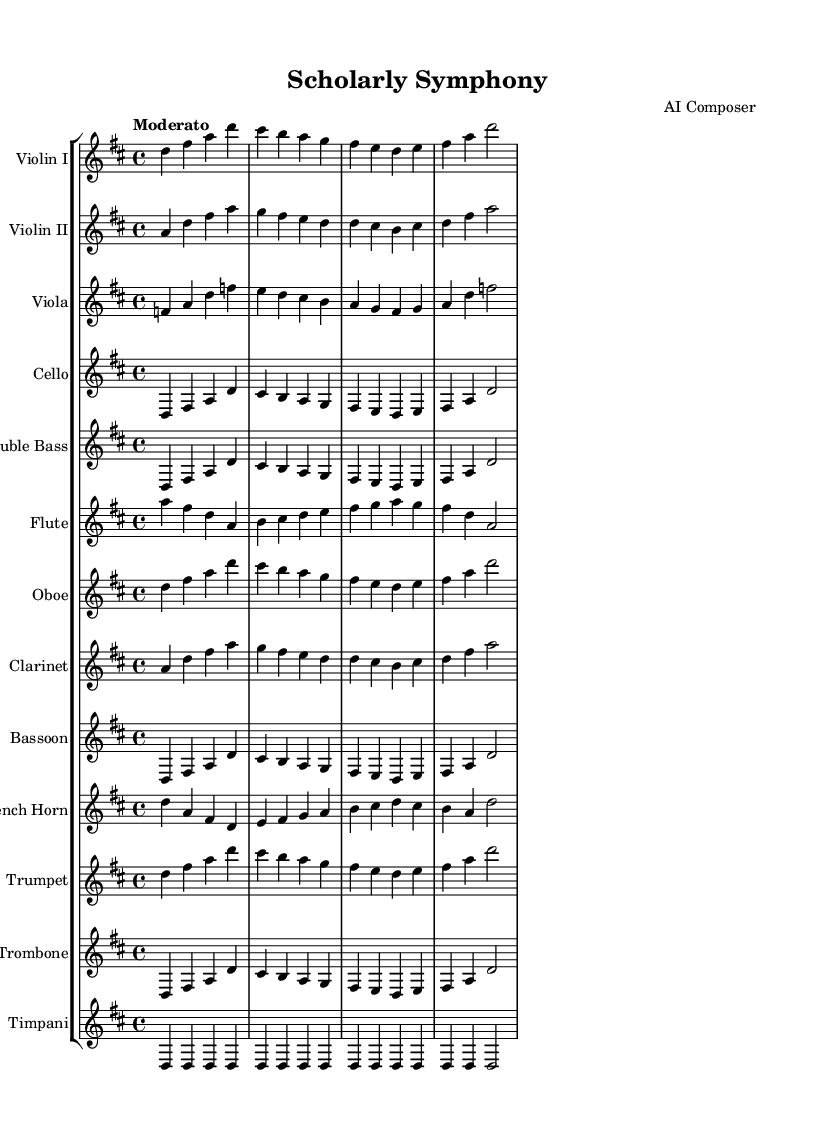What is the key signature of this music? The key signature is D major, which has two sharps (F# and C#). This can be determined by looking at the beginning of the staff where the sharps are placed.
Answer: D major What is the time signature of this music? The time signature is 4/4, indicated by the fraction at the beginning of the score. This means there are four beats in each measure and a quarter note receives one beat.
Answer: 4/4 What is the tempo marking for this symphony? The tempo marking is 'Moderato', which is a moderate speed. This is indicated at the beginning of the score, suggesting a pace that is neither too fast nor too slow.
Answer: Moderato How many different instrument groups are represented in the score? The score includes string instruments (e.g., violins, viola, cello, double bass) and woodwind instruments (e.g., flute, oboe, clarinet, bassoon) along with brass instruments (e.g., French horn, trumpet, trombone) and percussion (timpani). Counting them gives a total of four distinct groups.
Answer: Four Which instrument has the melody in the opening measures? In the opening measures, Violin I carries the melody as it plays a prominent and distinct part at the beginning of the score, often associated with leading themes in symphonic compositions.
Answer: Violin I What is the rhythmic pattern used for the first measure of Violin I? The first measure of Violin I has a rhythmic pattern consisting of four quarter notes played in a steady succession, which can be seen visually as four notes aligned with the measure.
Answer: Four quarter notes What element of education might this symphony symbolize through its instrumentation? The diverse instrumentation can symbolize the collaboration and harmony found in the pursuit of knowledge, as different instruments coming together represent different fields of study uniting for a common purpose.
Answer: Collaboration 